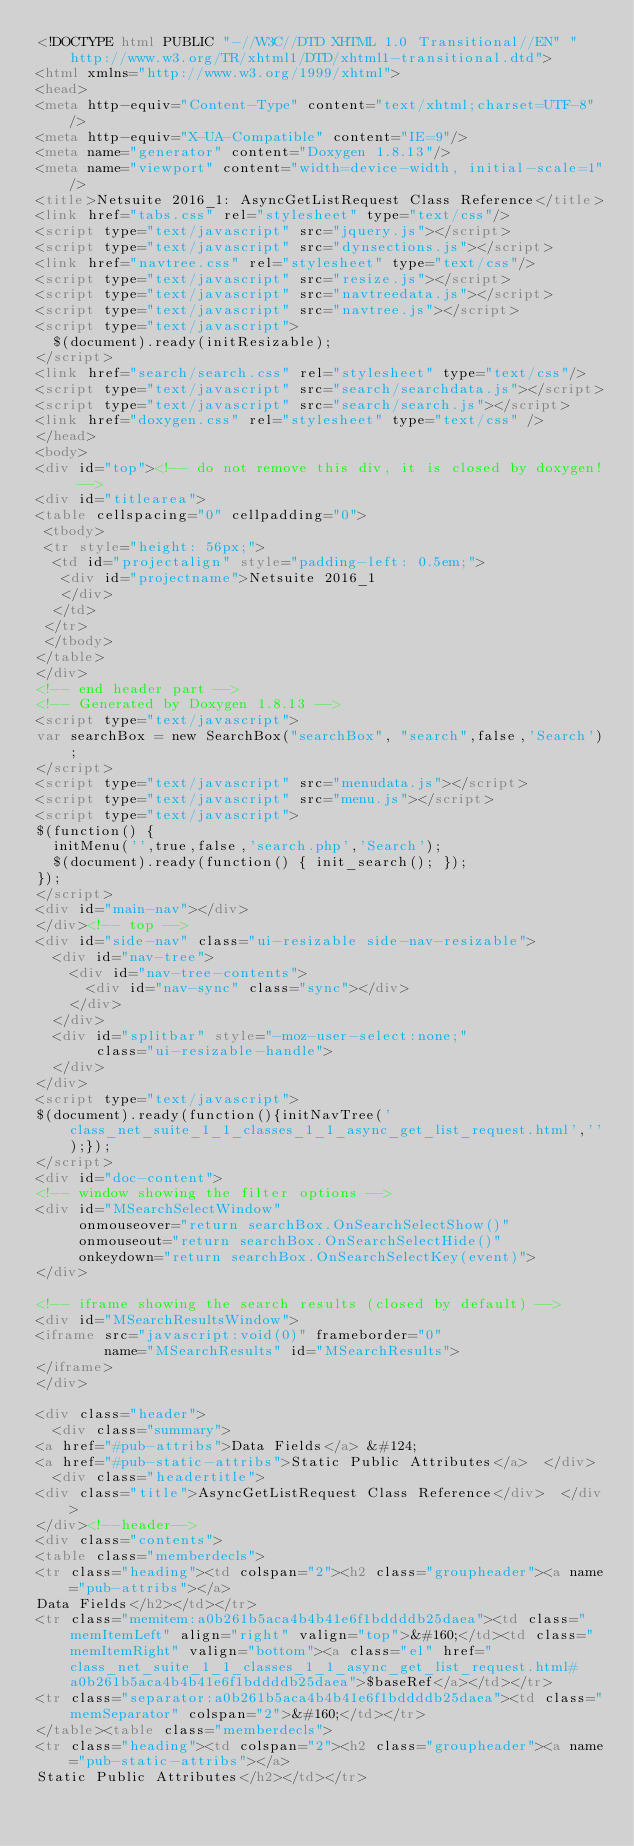<code> <loc_0><loc_0><loc_500><loc_500><_HTML_><!DOCTYPE html PUBLIC "-//W3C//DTD XHTML 1.0 Transitional//EN" "http://www.w3.org/TR/xhtml1/DTD/xhtml1-transitional.dtd">
<html xmlns="http://www.w3.org/1999/xhtml">
<head>
<meta http-equiv="Content-Type" content="text/xhtml;charset=UTF-8"/>
<meta http-equiv="X-UA-Compatible" content="IE=9"/>
<meta name="generator" content="Doxygen 1.8.13"/>
<meta name="viewport" content="width=device-width, initial-scale=1"/>
<title>Netsuite 2016_1: AsyncGetListRequest Class Reference</title>
<link href="tabs.css" rel="stylesheet" type="text/css"/>
<script type="text/javascript" src="jquery.js"></script>
<script type="text/javascript" src="dynsections.js"></script>
<link href="navtree.css" rel="stylesheet" type="text/css"/>
<script type="text/javascript" src="resize.js"></script>
<script type="text/javascript" src="navtreedata.js"></script>
<script type="text/javascript" src="navtree.js"></script>
<script type="text/javascript">
  $(document).ready(initResizable);
</script>
<link href="search/search.css" rel="stylesheet" type="text/css"/>
<script type="text/javascript" src="search/searchdata.js"></script>
<script type="text/javascript" src="search/search.js"></script>
<link href="doxygen.css" rel="stylesheet" type="text/css" />
</head>
<body>
<div id="top"><!-- do not remove this div, it is closed by doxygen! -->
<div id="titlearea">
<table cellspacing="0" cellpadding="0">
 <tbody>
 <tr style="height: 56px;">
  <td id="projectalign" style="padding-left: 0.5em;">
   <div id="projectname">Netsuite 2016_1
   </div>
  </td>
 </tr>
 </tbody>
</table>
</div>
<!-- end header part -->
<!-- Generated by Doxygen 1.8.13 -->
<script type="text/javascript">
var searchBox = new SearchBox("searchBox", "search",false,'Search');
</script>
<script type="text/javascript" src="menudata.js"></script>
<script type="text/javascript" src="menu.js"></script>
<script type="text/javascript">
$(function() {
  initMenu('',true,false,'search.php','Search');
  $(document).ready(function() { init_search(); });
});
</script>
<div id="main-nav"></div>
</div><!-- top -->
<div id="side-nav" class="ui-resizable side-nav-resizable">
  <div id="nav-tree">
    <div id="nav-tree-contents">
      <div id="nav-sync" class="sync"></div>
    </div>
  </div>
  <div id="splitbar" style="-moz-user-select:none;" 
       class="ui-resizable-handle">
  </div>
</div>
<script type="text/javascript">
$(document).ready(function(){initNavTree('class_net_suite_1_1_classes_1_1_async_get_list_request.html','');});
</script>
<div id="doc-content">
<!-- window showing the filter options -->
<div id="MSearchSelectWindow"
     onmouseover="return searchBox.OnSearchSelectShow()"
     onmouseout="return searchBox.OnSearchSelectHide()"
     onkeydown="return searchBox.OnSearchSelectKey(event)">
</div>

<!-- iframe showing the search results (closed by default) -->
<div id="MSearchResultsWindow">
<iframe src="javascript:void(0)" frameborder="0" 
        name="MSearchResults" id="MSearchResults">
</iframe>
</div>

<div class="header">
  <div class="summary">
<a href="#pub-attribs">Data Fields</a> &#124;
<a href="#pub-static-attribs">Static Public Attributes</a>  </div>
  <div class="headertitle">
<div class="title">AsyncGetListRequest Class Reference</div>  </div>
</div><!--header-->
<div class="contents">
<table class="memberdecls">
<tr class="heading"><td colspan="2"><h2 class="groupheader"><a name="pub-attribs"></a>
Data Fields</h2></td></tr>
<tr class="memitem:a0b261b5aca4b4b41e6f1bddddb25daea"><td class="memItemLeft" align="right" valign="top">&#160;</td><td class="memItemRight" valign="bottom"><a class="el" href="class_net_suite_1_1_classes_1_1_async_get_list_request.html#a0b261b5aca4b4b41e6f1bddddb25daea">$baseRef</a></td></tr>
<tr class="separator:a0b261b5aca4b4b41e6f1bddddb25daea"><td class="memSeparator" colspan="2">&#160;</td></tr>
</table><table class="memberdecls">
<tr class="heading"><td colspan="2"><h2 class="groupheader"><a name="pub-static-attribs"></a>
Static Public Attributes</h2></td></tr></code> 